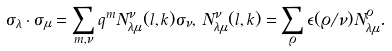Convert formula to latex. <formula><loc_0><loc_0><loc_500><loc_500>\sigma _ { \lambda } \cdot \sigma _ { \mu } = \sum _ { m , \nu } q ^ { m } N _ { \lambda \mu } ^ { \nu } ( l , k ) \sigma _ { \nu } , \, N _ { \lambda \mu } ^ { \nu } ( l , k ) = \sum _ { \varrho } \epsilon ( \varrho / \nu ) N _ { \lambda \mu } ^ { \varrho } .</formula> 